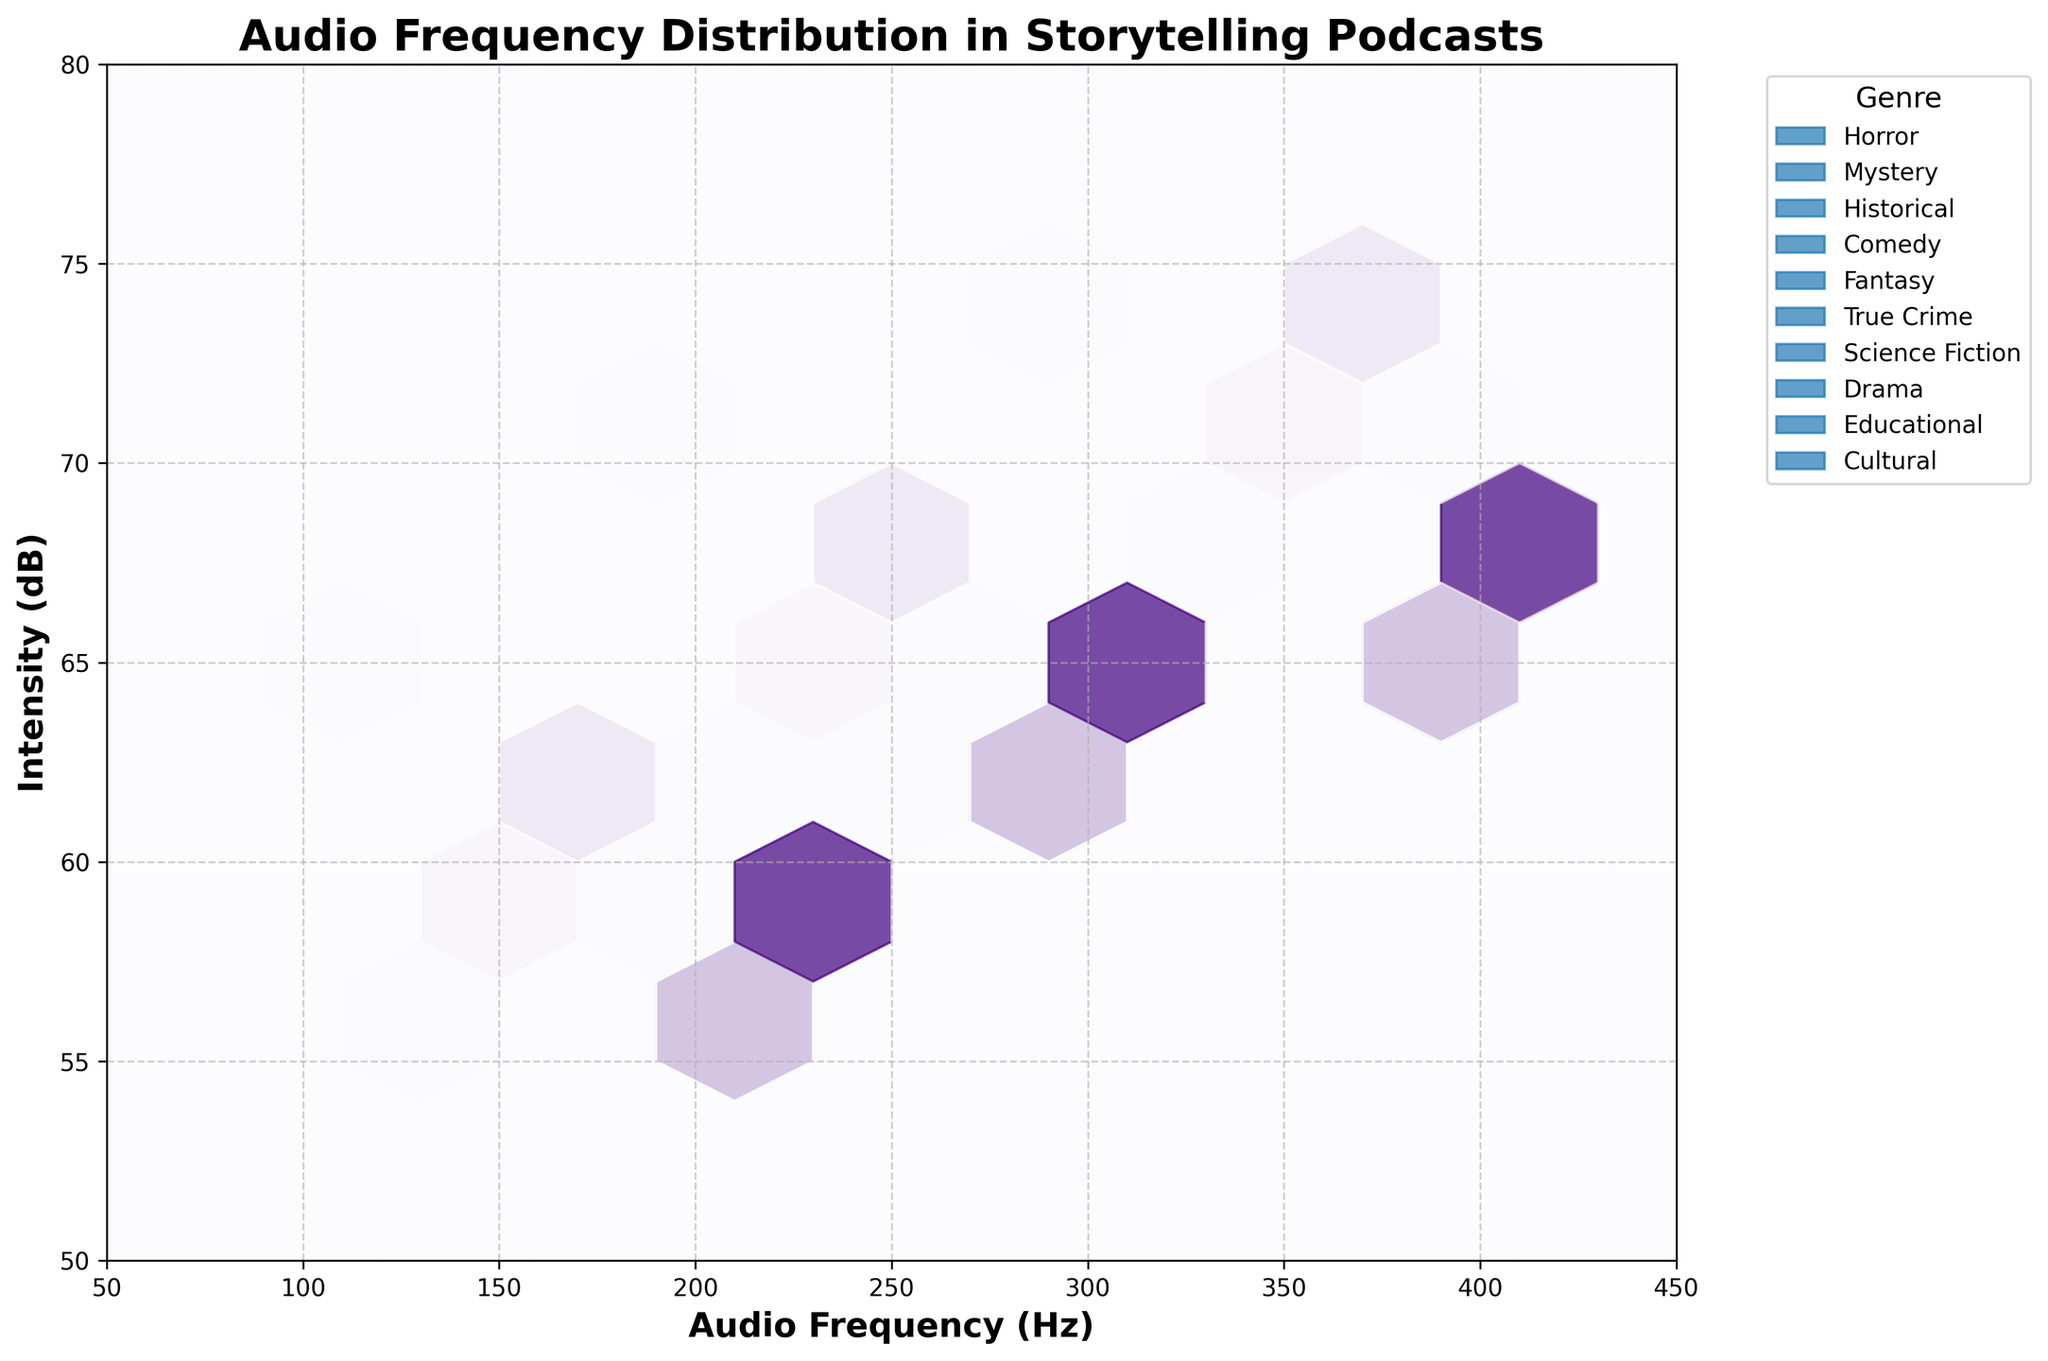what is the title of the figure? The title is displayed at the top center of the plot and reads "Audio Frequency Distribution in Storytelling Podcasts"
Answer: Audio Frequency Distribution in Storytelling Podcasts How is the audio frequency measured in the figure? The x-axis is labeled "Audio Frequency (Hz)" indicating the audio frequency is measured in Hertz
Answer: Hertz Which genre has the highest audio intensity in the data and what is the value? Examining the hexbin plot, the highest intensity recorded is 75 dB for the Horror genre at an audio frequency (Hz) of 300.
Answer: Horror, 75 dB What are the x-axis and y-axis ranges displayed on the figure? The x-axis ranges from 50 to 450 Hz, and the y-axis ranges from 50 to 80 dB, as indicated by the x and y axis limits and ticks respectively
Answer: 50 to 450 Hz, 50 to 80 dB Which genre appears to have the widest spread in audio frequency? By observing the distribution of the hexbin bins, the Cultural genre appears to cover a wider frequency range, from approximately 210 Hz to 410 Hz
Answer: Cultural Determine the average intensity of the Comedy genre. The intensities for Comedy are 58, 64, and 70 dB. Summing them: 58 + 64 + 70 = 192. Dividing by 3, the average intensity is 192/3 = 64 dB
Answer: 64 dB How many distinct genres are represented in the figure? From the legend, one can count each unique color to identify that there are 10 distinct genres represented in the plot.
Answer: 10 genres Which genre has the least variation in intensity? By looking at the hexbin distribution, the Historical genre appears to have the least variation in intensity, with recorded values at 55 dB, 62 dB, and 68 dB, respectively
Answer: Historical Is there a genre that shows a general trend of increasing intensity with increasing audio frequency? By observing the bins for the Horror genre, it is noticeable that as the frequency increases, the intensity also tends to increase (from 65 dB at 100 Hz to 75 dB at 300 Hz)
Answer: Horror What is the midpoint frequency value for Science Fiction genres? The frequencies for Science Fiction are 140, 240, and 340 Hz. The midpoint (median) of these values is 240 Hz
Answer: 240 Hz 